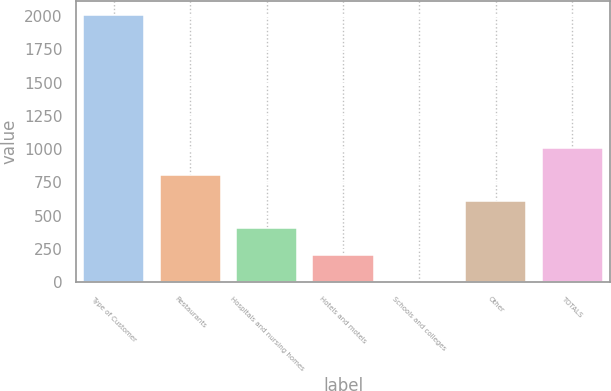Convert chart to OTSL. <chart><loc_0><loc_0><loc_500><loc_500><bar_chart><fcel>Type of Customer<fcel>Restaurants<fcel>Hospitals and nursing homes<fcel>Hotels and motels<fcel>Schools and colleges<fcel>Other<fcel>TOTALS<nl><fcel>2010<fcel>807<fcel>406<fcel>205.5<fcel>5<fcel>606.5<fcel>1007.5<nl></chart> 